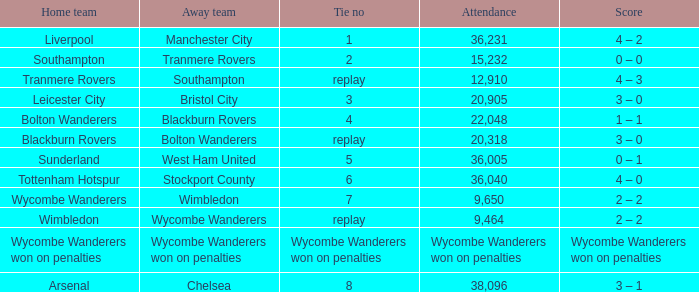What was the score of having a tie of 1? 4 – 2. 